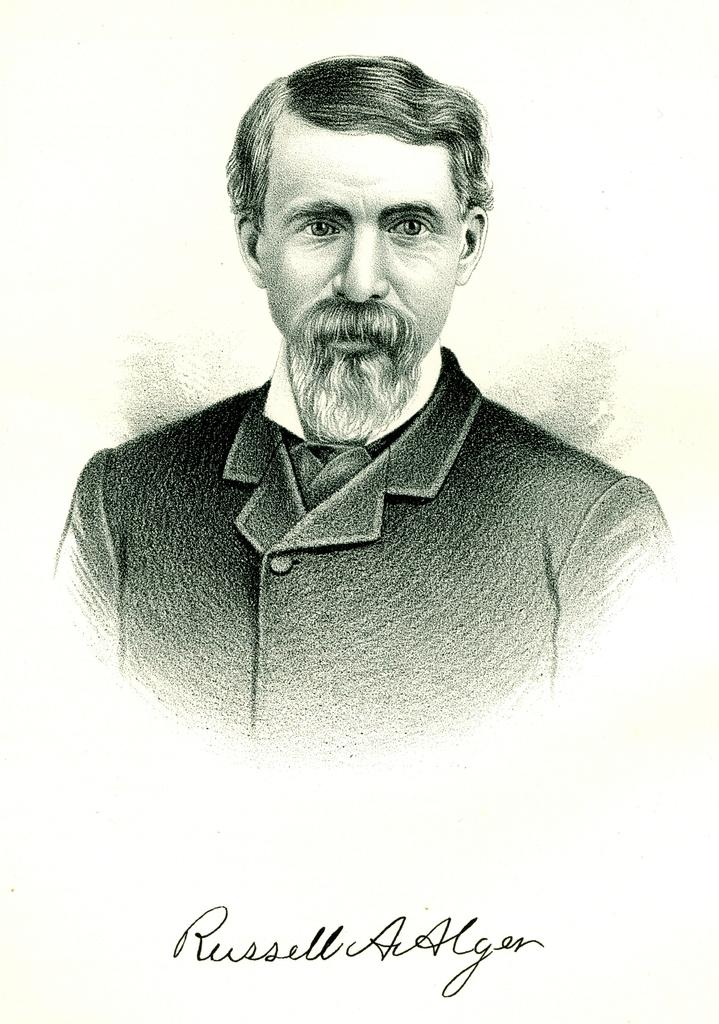What is depicted in the image? There is a painting of a man in the image. Can you identify any additional details about the painting? Yes, there is a name at the bottom of the painting. What type of sweater is the man wearing in the painting? The image does not provide enough detail to determine the type of sweater the man might be wearing, as it is a painting and not a photograph. 